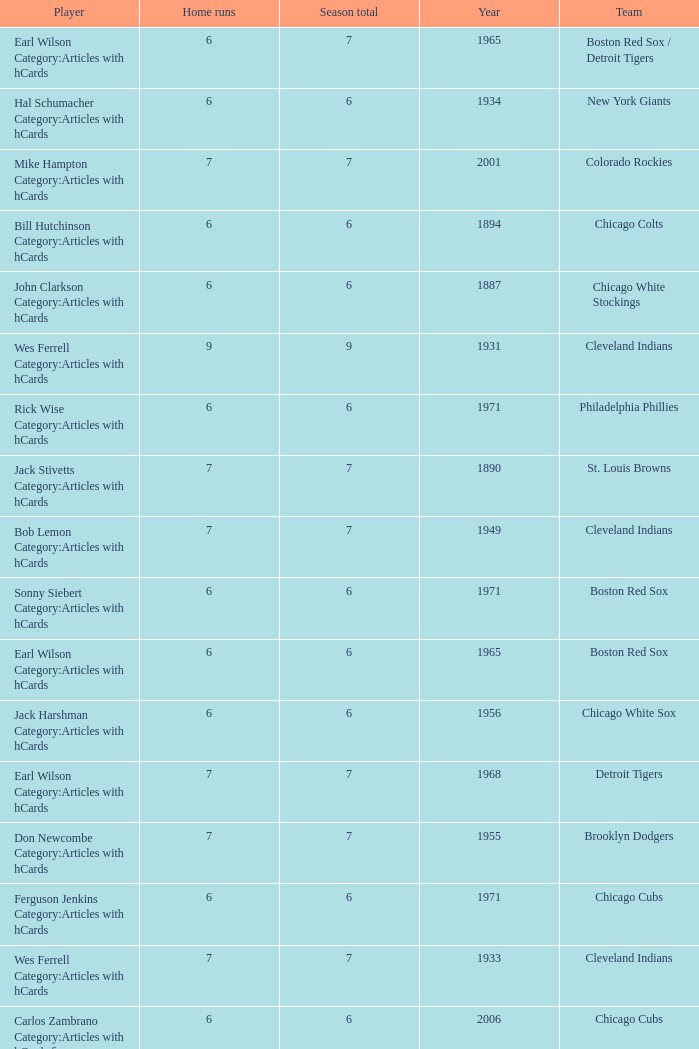Tell me the highest home runs for cleveland indians years before 1931 None. 